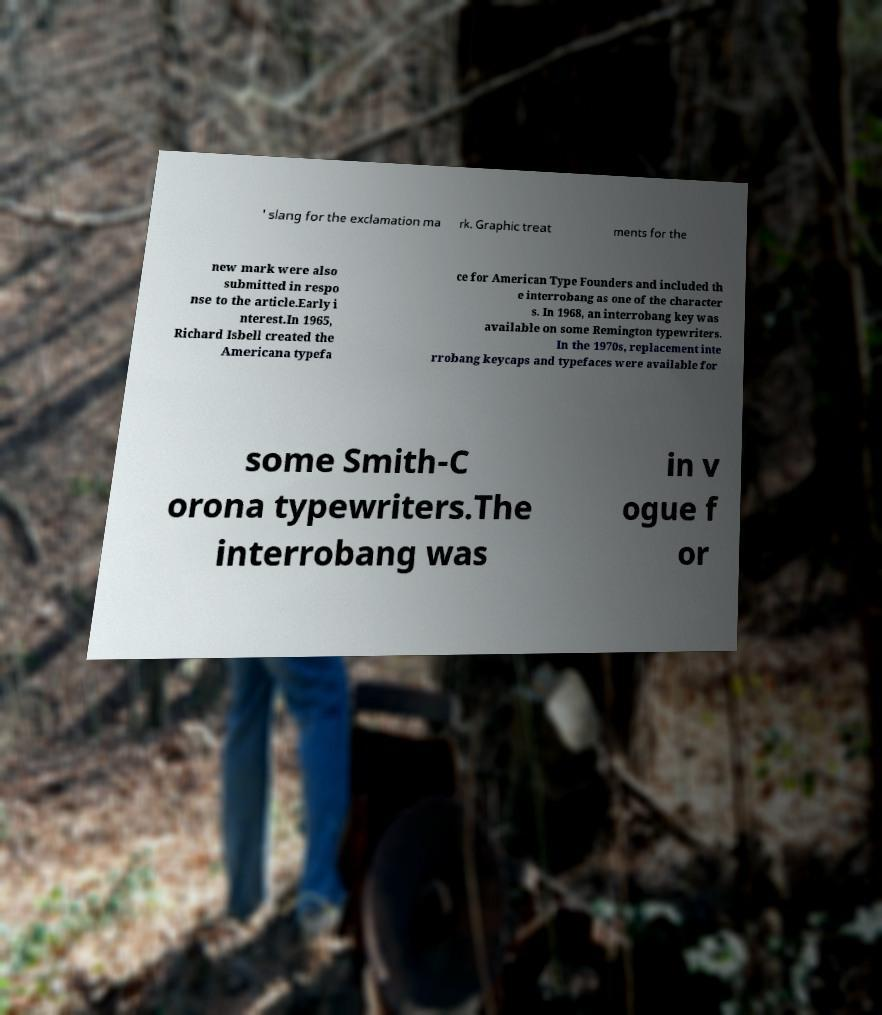What messages or text are displayed in this image? I need them in a readable, typed format. ' slang for the exclamation ma rk. Graphic treat ments for the new mark were also submitted in respo nse to the article.Early i nterest.In 1965, Richard Isbell created the Americana typefa ce for American Type Founders and included th e interrobang as one of the character s. In 1968, an interrobang key was available on some Remington typewriters. In the 1970s, replacement inte rrobang keycaps and typefaces were available for some Smith-C orona typewriters.The interrobang was in v ogue f or 